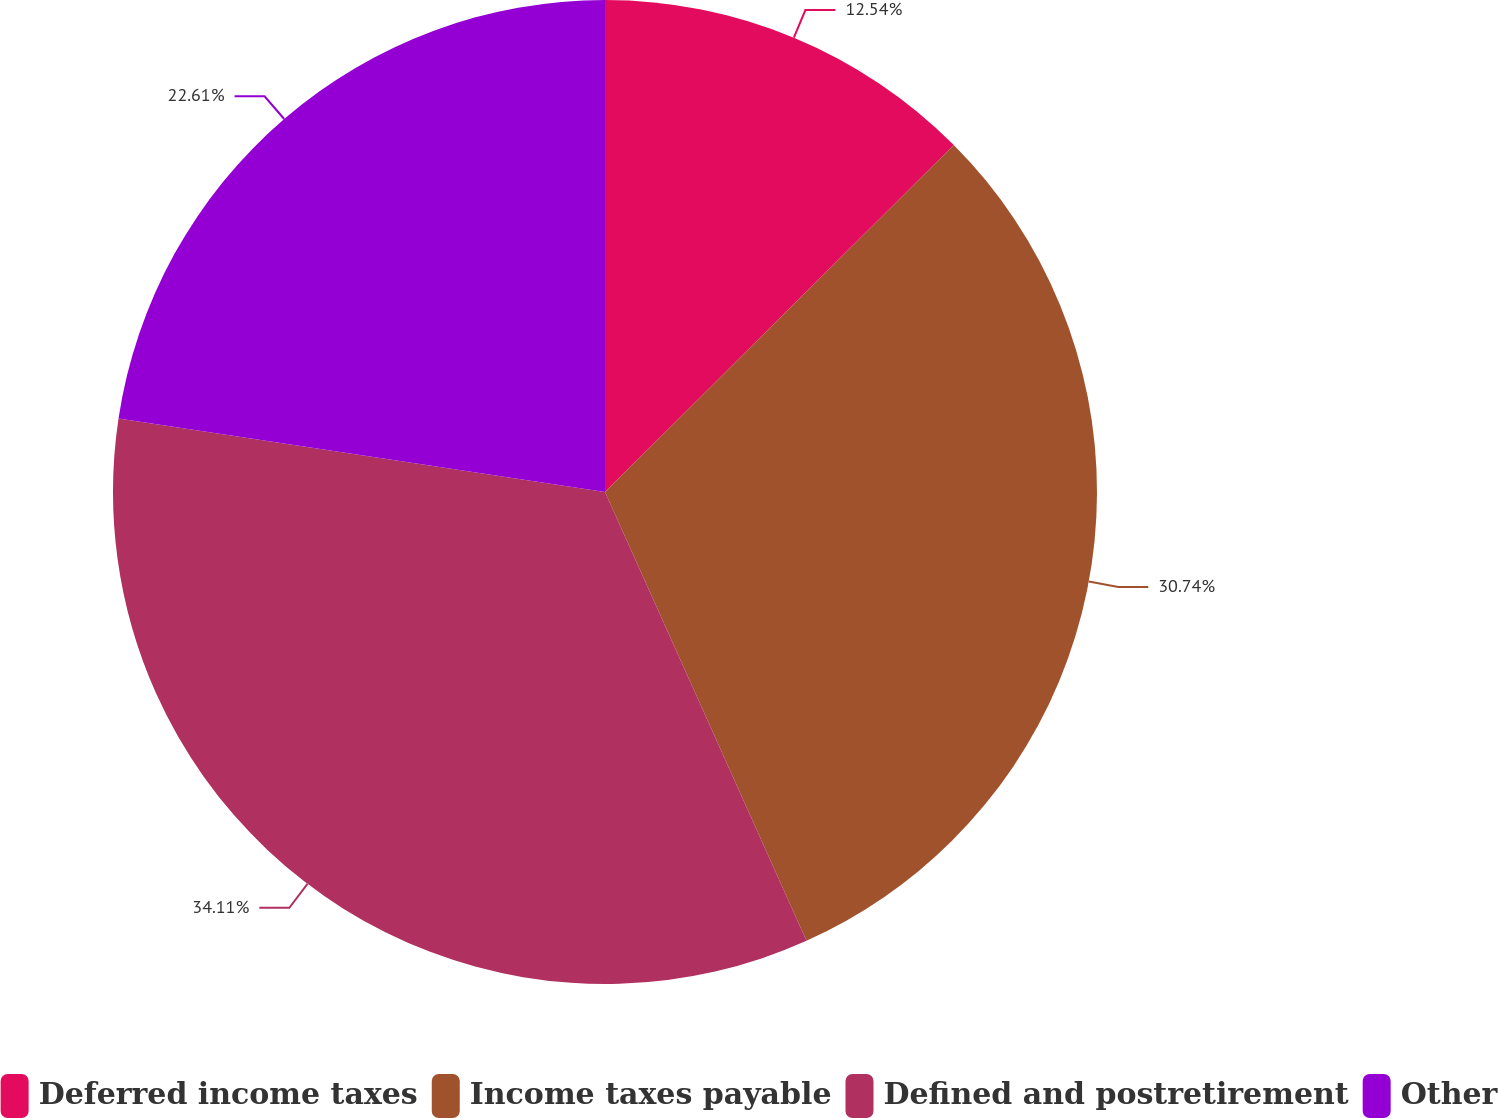<chart> <loc_0><loc_0><loc_500><loc_500><pie_chart><fcel>Deferred income taxes<fcel>Income taxes payable<fcel>Defined and postretirement<fcel>Other<nl><fcel>12.54%<fcel>30.74%<fcel>34.1%<fcel>22.61%<nl></chart> 